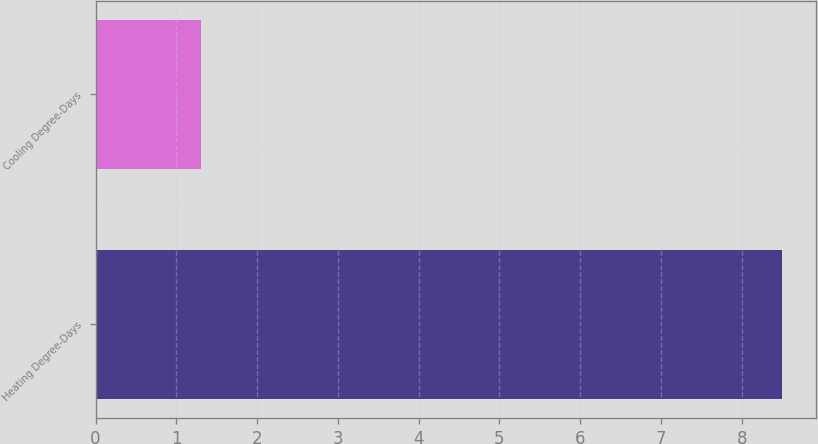Convert chart to OTSL. <chart><loc_0><loc_0><loc_500><loc_500><bar_chart><fcel>Heating Degree-Days<fcel>Cooling Degree-Days<nl><fcel>8.5<fcel>1.3<nl></chart> 